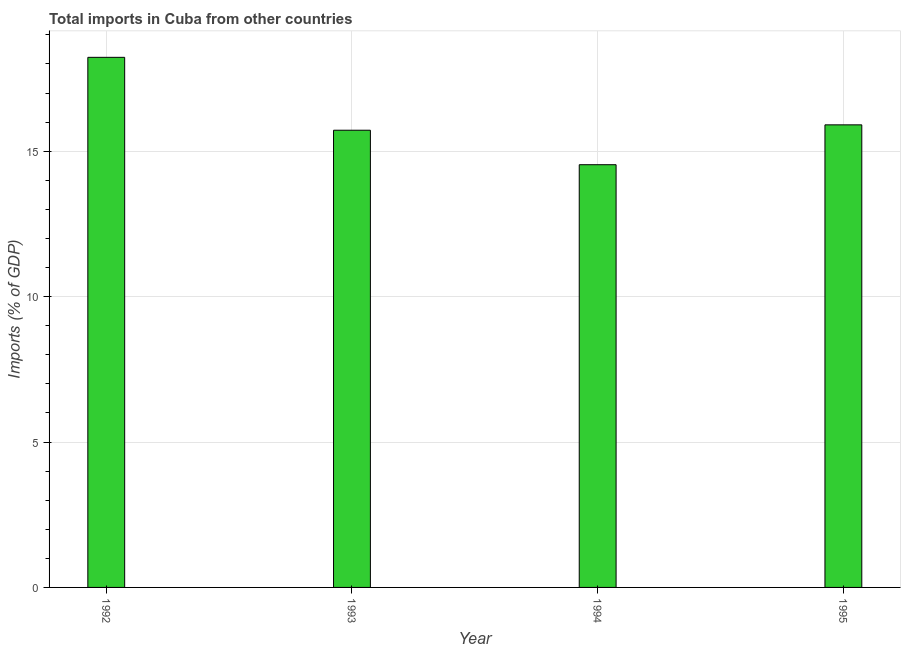What is the title of the graph?
Offer a terse response. Total imports in Cuba from other countries. What is the label or title of the X-axis?
Your answer should be very brief. Year. What is the label or title of the Y-axis?
Give a very brief answer. Imports (% of GDP). What is the total imports in 1994?
Ensure brevity in your answer.  14.54. Across all years, what is the maximum total imports?
Make the answer very short. 18.23. Across all years, what is the minimum total imports?
Your response must be concise. 14.54. In which year was the total imports minimum?
Ensure brevity in your answer.  1994. What is the sum of the total imports?
Your answer should be very brief. 64.39. What is the difference between the total imports in 1993 and 1994?
Provide a succinct answer. 1.19. What is the average total imports per year?
Provide a short and direct response. 16.1. What is the median total imports?
Your response must be concise. 15.81. In how many years, is the total imports greater than 11 %?
Provide a short and direct response. 4. What is the ratio of the total imports in 1993 to that in 1994?
Your answer should be very brief. 1.08. Is the total imports in 1994 less than that in 1995?
Ensure brevity in your answer.  Yes. What is the difference between the highest and the second highest total imports?
Your response must be concise. 2.32. What is the difference between the highest and the lowest total imports?
Your answer should be compact. 3.69. In how many years, is the total imports greater than the average total imports taken over all years?
Your response must be concise. 1. Are all the bars in the graph horizontal?
Offer a very short reply. No. How many years are there in the graph?
Your answer should be very brief. 4. What is the difference between two consecutive major ticks on the Y-axis?
Offer a very short reply. 5. What is the Imports (% of GDP) of 1992?
Ensure brevity in your answer.  18.23. What is the Imports (% of GDP) of 1993?
Provide a short and direct response. 15.72. What is the Imports (% of GDP) of 1994?
Your answer should be very brief. 14.54. What is the Imports (% of GDP) in 1995?
Provide a succinct answer. 15.91. What is the difference between the Imports (% of GDP) in 1992 and 1993?
Provide a succinct answer. 2.51. What is the difference between the Imports (% of GDP) in 1992 and 1994?
Your answer should be compact. 3.69. What is the difference between the Imports (% of GDP) in 1992 and 1995?
Your answer should be compact. 2.32. What is the difference between the Imports (% of GDP) in 1993 and 1994?
Provide a short and direct response. 1.19. What is the difference between the Imports (% of GDP) in 1993 and 1995?
Your answer should be compact. -0.19. What is the difference between the Imports (% of GDP) in 1994 and 1995?
Provide a short and direct response. -1.37. What is the ratio of the Imports (% of GDP) in 1992 to that in 1993?
Make the answer very short. 1.16. What is the ratio of the Imports (% of GDP) in 1992 to that in 1994?
Your answer should be very brief. 1.25. What is the ratio of the Imports (% of GDP) in 1992 to that in 1995?
Your response must be concise. 1.15. What is the ratio of the Imports (% of GDP) in 1993 to that in 1994?
Offer a very short reply. 1.08. What is the ratio of the Imports (% of GDP) in 1993 to that in 1995?
Offer a very short reply. 0.99. What is the ratio of the Imports (% of GDP) in 1994 to that in 1995?
Provide a succinct answer. 0.91. 